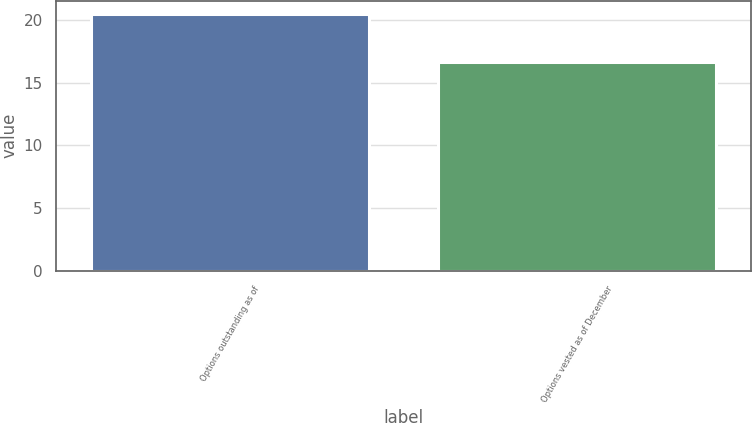<chart> <loc_0><loc_0><loc_500><loc_500><bar_chart><fcel>Options outstanding as of<fcel>Options vested as of December<nl><fcel>20.51<fcel>16.68<nl></chart> 